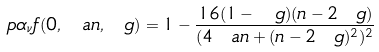<formula> <loc_0><loc_0><loc_500><loc_500>\ p { \alpha _ { \nu } } f ( 0 , \ a n , \ g ) = 1 - \frac { 1 6 ( 1 - \ g ) ( n - 2 \ g ) } { ( 4 \ a n + ( n - 2 \ g ) ^ { 2 } ) ^ { 2 } }</formula> 